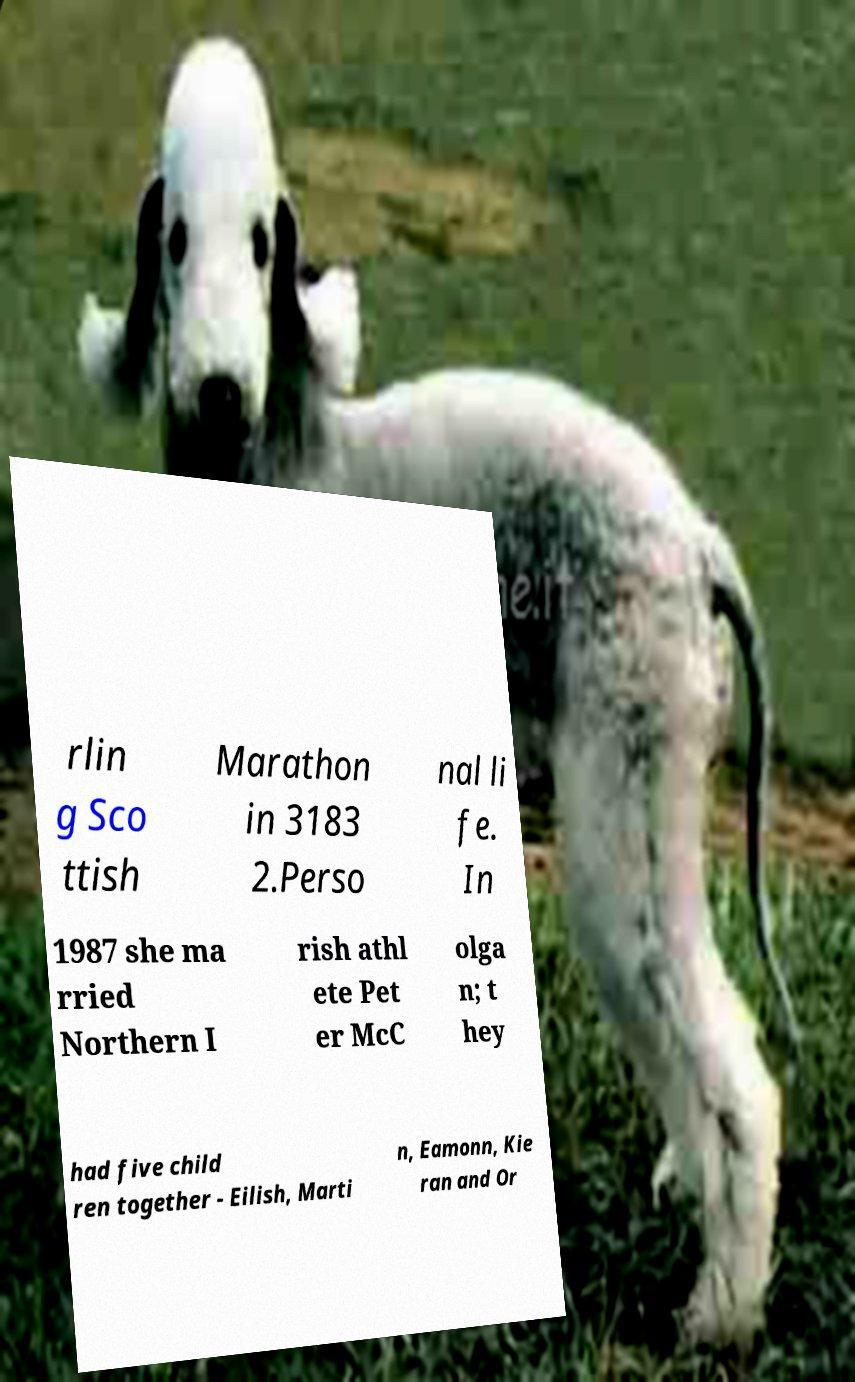Please identify and transcribe the text found in this image. rlin g Sco ttish Marathon in 3183 2.Perso nal li fe. In 1987 she ma rried Northern I rish athl ete Pet er McC olga n; t hey had five child ren together - Eilish, Marti n, Eamonn, Kie ran and Or 